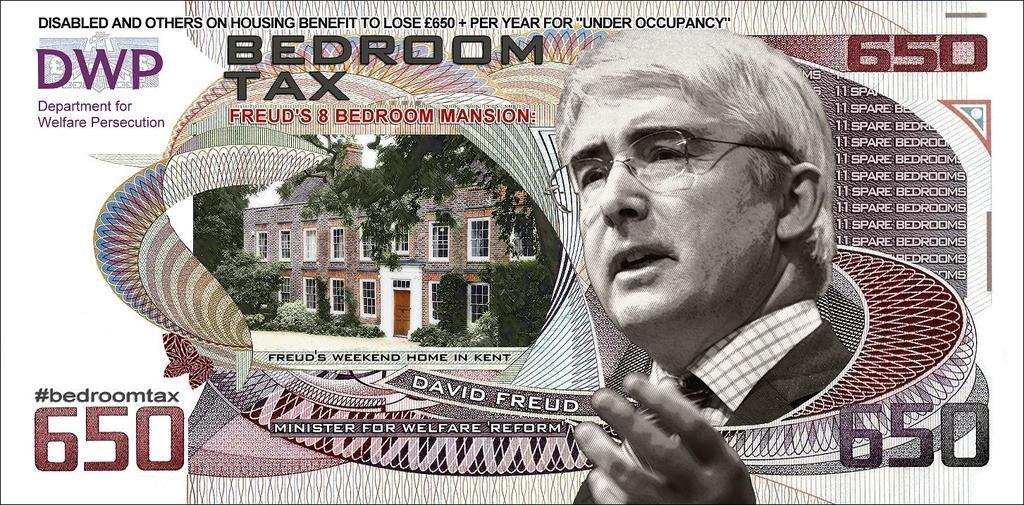Describe this image in one or two sentences. This image consists of a currency note. In which there is a building and a picture of a man. At the top, there is a text. 